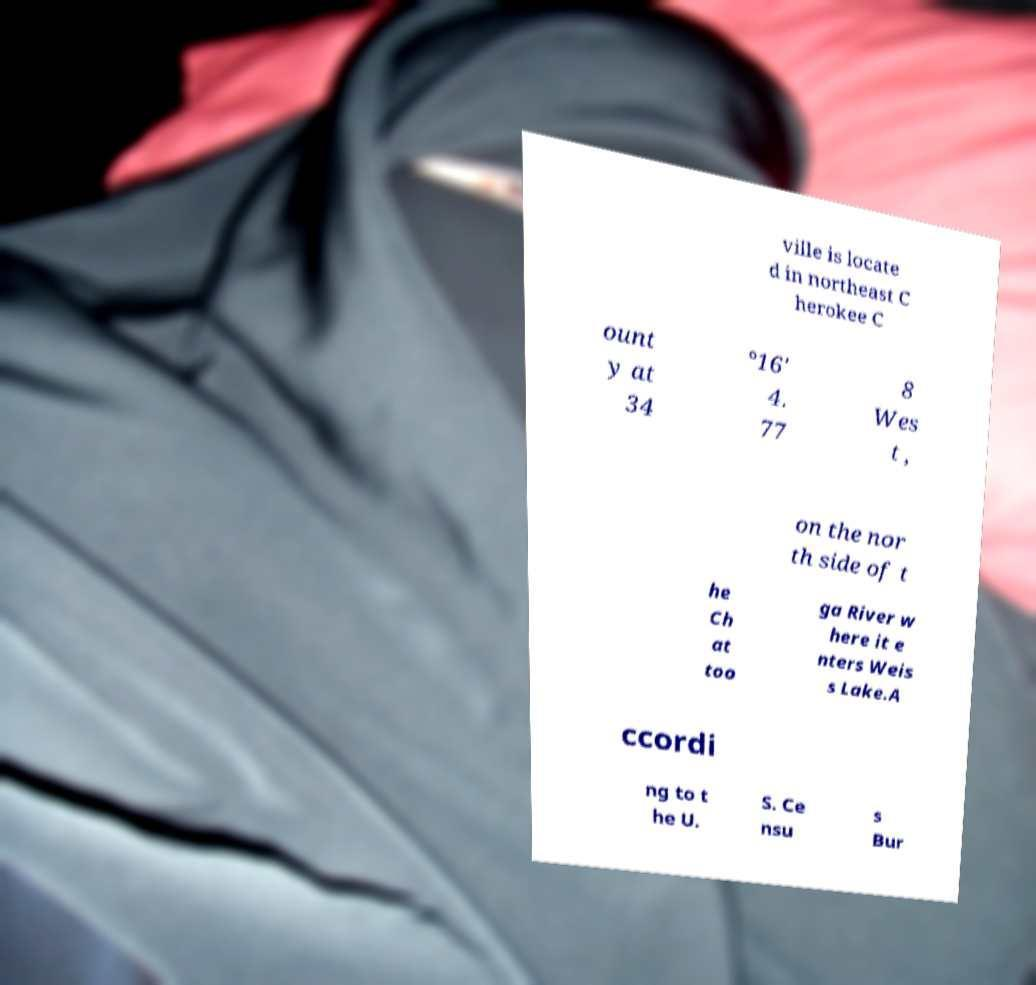Please read and relay the text visible in this image. What does it say? ville is locate d in northeast C herokee C ount y at 34 °16' 4. 77 8 Wes t , on the nor th side of t he Ch at too ga River w here it e nters Weis s Lake.A ccordi ng to t he U. S. Ce nsu s Bur 